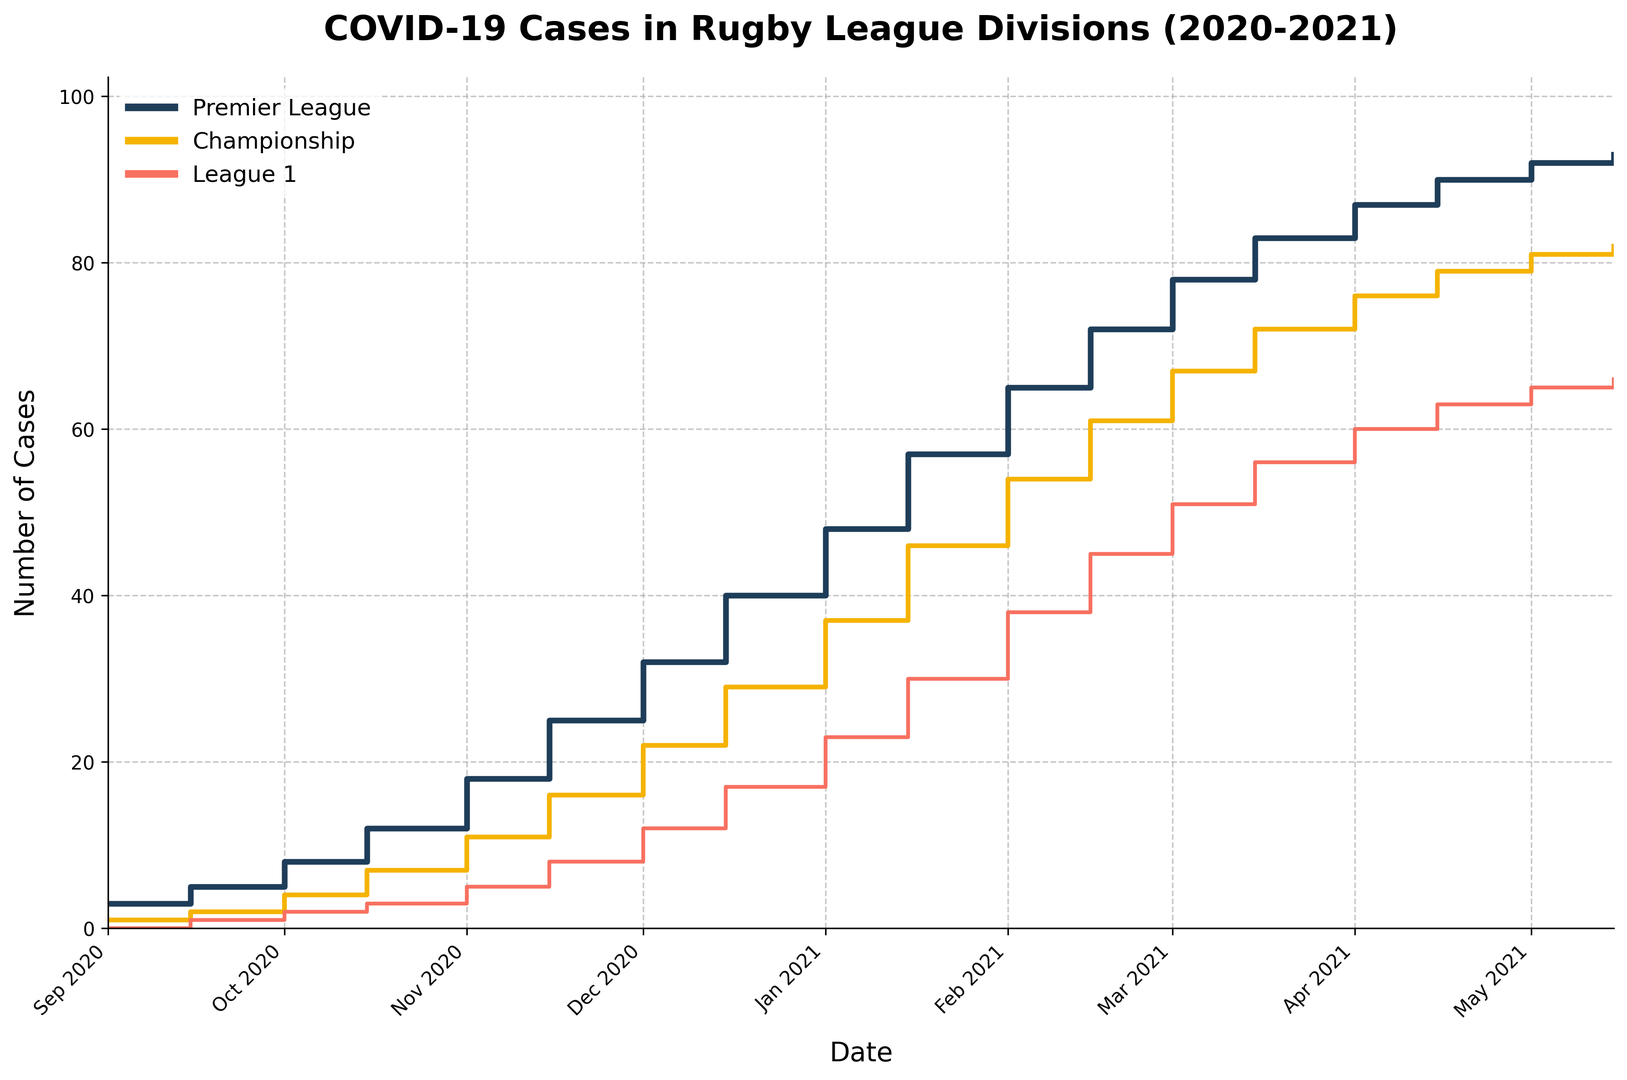what is the total increase in COVID-19 cases in the Premier League from September 2020 to May 2021? Look at the number of cases in the Premier League on 2020-09-01, which is 3 cases. Compare this to the number of cases on 2021-05-15, which is 93. The increase is 93 - 3 = 90 cases.
Answer: 90 Which division had the highest total number of COVID-19 cases by May 2021? By visually comparing the final heights of the lines on the plot in May 2021, the Premier League had the highest with 93 cases.
Answer: Premier League Between January 2021 and April 2021, which division exhibited the most significant increment in COVID-19 cases? From the plot, the Premier League increased from 48 cases in January 2021 to 87 cases in April 2021, an increase of 39 cases. The Championship increased from 37 to 76, an increase of 39 cases. League 1 increased from 23 to 60, an increase of 37 cases. Hence, the Premier League and Championship had the largest increment.
Answer: Premier League and Championship On what date did the League 1 division reach 30 COVID-19 cases? Look at the plot where the League 1 (orange line) reaches 30 cases, which is on 2021-01-15.
Answer: 2021-01-15 How does the growth trend of COVID-19 cases in the Championship division compare to the Premier League from November to December 2020? From the plot, the Championship increases from 11 to 22 cases in November to December 2020, an increase of 11 cases. The Premier League increases from 18 to 32, an increase of 14 cases. Despite both divisions showing noticeable increases, the Premier League had a higher increase.
Answer: Premier League grows faster What is the average number of COVID-19 cases in the Premier League over the entire period? The Premier League cases over all dates are: 3, 5, 8, 12, 18, 25, 32, 40, 48, 57, 65, 72, 78, 83, 87, 90, 92, 93. The sum is 894, the number of data points is 18, so the average is 894/18 = 49.67.
Answer: 49.67 Which division had the smallest increase in COVID-19 cases from October to December 2020? On October 2020, the counts are: Premier League 8, Championship 4, League 1 2. On December 2020, the counts are: Premier League 32, Championship 22, League 1 12. The increases are: Premier League (32 - 8 = 24), Championship (22 - 4 = 18), League 1 (12 - 2 = 10). League 1 had the smallest increase.
Answer: League 1 